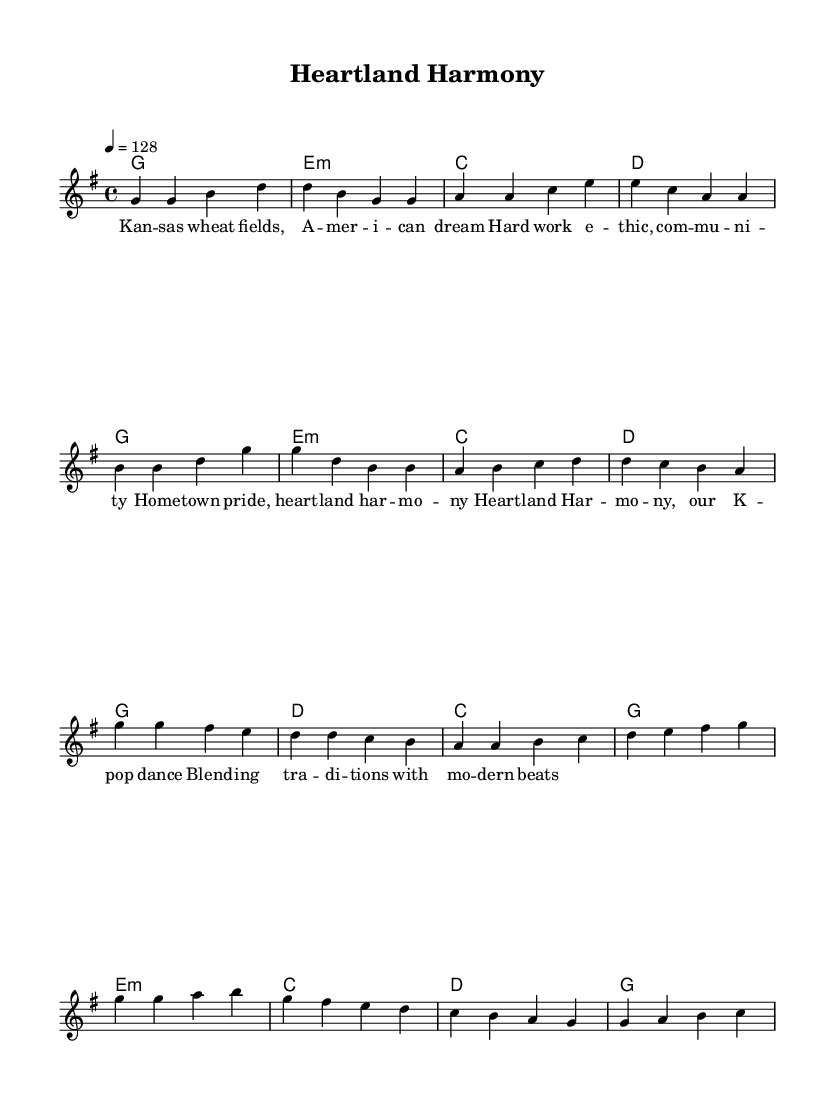What is the key signature of this music? The key signature is G major, which has one sharp (F#). This can be identified from the key signature indicated at the beginning of the piece.
Answer: G major What is the time signature of this music? The time signature is 4/4, which means there are four beats in each measure. This can be seen at the beginning of the score where the time signature is specified.
Answer: 4/4 What is the tempo marking for this piece? The tempo marking is 128 beats per minute, which tells the performer the speed at which to play the music. This is indicated by the number next to the tempo marking at the beginning of the score.
Answer: 128 How many measures are in the verse section? The verse section contains 8 measures, which can be counted from the start of the verse until just before the chorus begins. This is determined by visually identifying the measures in the melody part.
Answer: 8 What type of chords are primarily used in the harmonies? The harmonies mostly utilize major and minor chords, which can be identified by looking at the written chord names next to the melody notes. The chords include G major, E minor, C major, and D major.
Answer: Major and minor What traditional values are illustrated in the lyrics? The lyrics express themes of hard work, community, and hometown pride, reflecting the American heartland values. This can be discerned by reading through the lyrics provided along with the melody which emphasize these themes.
Answer: Hard work, community, hometown pride What musical genre does this piece represent? This piece represents K-Pop, which is characterized by its catchy melodies, danceable beats, and modern production. The energetic dance feel is also typical of K-Pop music, as noted from the tempo and style of the composition.
Answer: K-Pop 